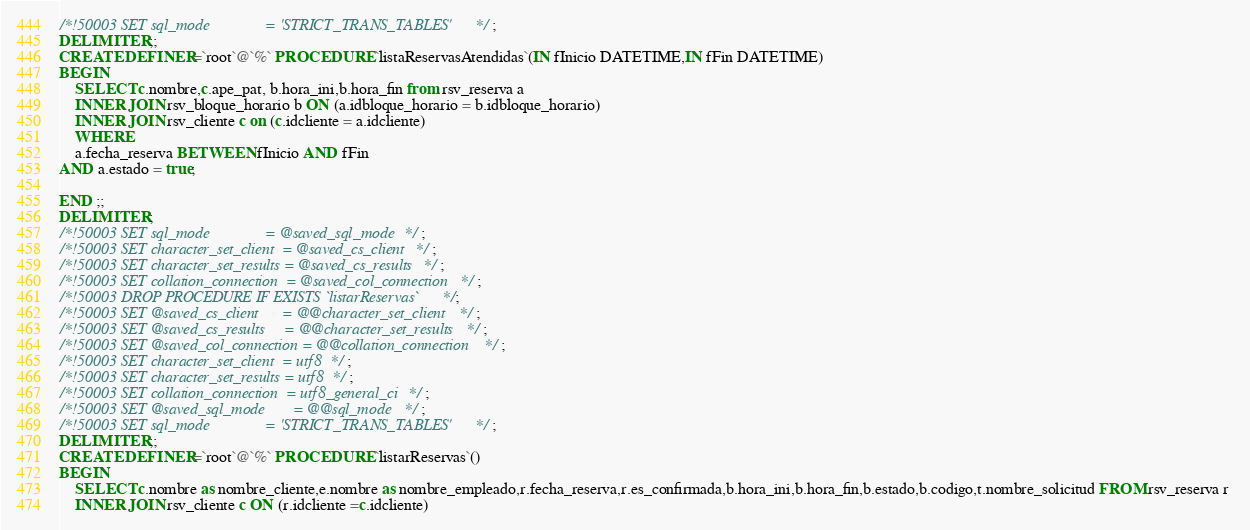Convert code to text. <code><loc_0><loc_0><loc_500><loc_500><_SQL_>/*!50003 SET sql_mode              = 'STRICT_TRANS_TABLES' */ ;
DELIMITER ;;
CREATE DEFINER=`root`@`%` PROCEDURE `listaReservasAtendidas`(IN fInicio DATETIME,IN fFin DATETIME)
BEGIN
	SELECT c.nombre,c.ape_pat, b.hora_ini,b.hora_fin from rsv_reserva a 
	INNER JOIN rsv_bloque_horario b ON (a.idbloque_horario = b.idbloque_horario)
	INNER JOIN rsv_cliente c on (c.idcliente = a.idcliente)
	WHERE 
	a.fecha_reserva BETWEEN fInicio AND fFin 
AND a.estado = true;
	
END ;;
DELIMITER ;
/*!50003 SET sql_mode              = @saved_sql_mode */ ;
/*!50003 SET character_set_client  = @saved_cs_client */ ;
/*!50003 SET character_set_results = @saved_cs_results */ ;
/*!50003 SET collation_connection  = @saved_col_connection */ ;
/*!50003 DROP PROCEDURE IF EXISTS `listarReservas` */;
/*!50003 SET @saved_cs_client      = @@character_set_client */ ;
/*!50003 SET @saved_cs_results     = @@character_set_results */ ;
/*!50003 SET @saved_col_connection = @@collation_connection */ ;
/*!50003 SET character_set_client  = utf8 */ ;
/*!50003 SET character_set_results = utf8 */ ;
/*!50003 SET collation_connection  = utf8_general_ci */ ;
/*!50003 SET @saved_sql_mode       = @@sql_mode */ ;
/*!50003 SET sql_mode              = 'STRICT_TRANS_TABLES' */ ;
DELIMITER ;;
CREATE DEFINER=`root`@`%` PROCEDURE `listarReservas`()
BEGIN
	SELECT c.nombre as nombre_cliente,e.nombre as nombre_empleado,r.fecha_reserva,r.es_confirmada,b.hora_ini,b.hora_fin,b.estado,b.codigo,t.nombre_solicitud FROM rsv_reserva r 
	INNER JOIN rsv_cliente c ON (r.idcliente =c.idcliente)</code> 